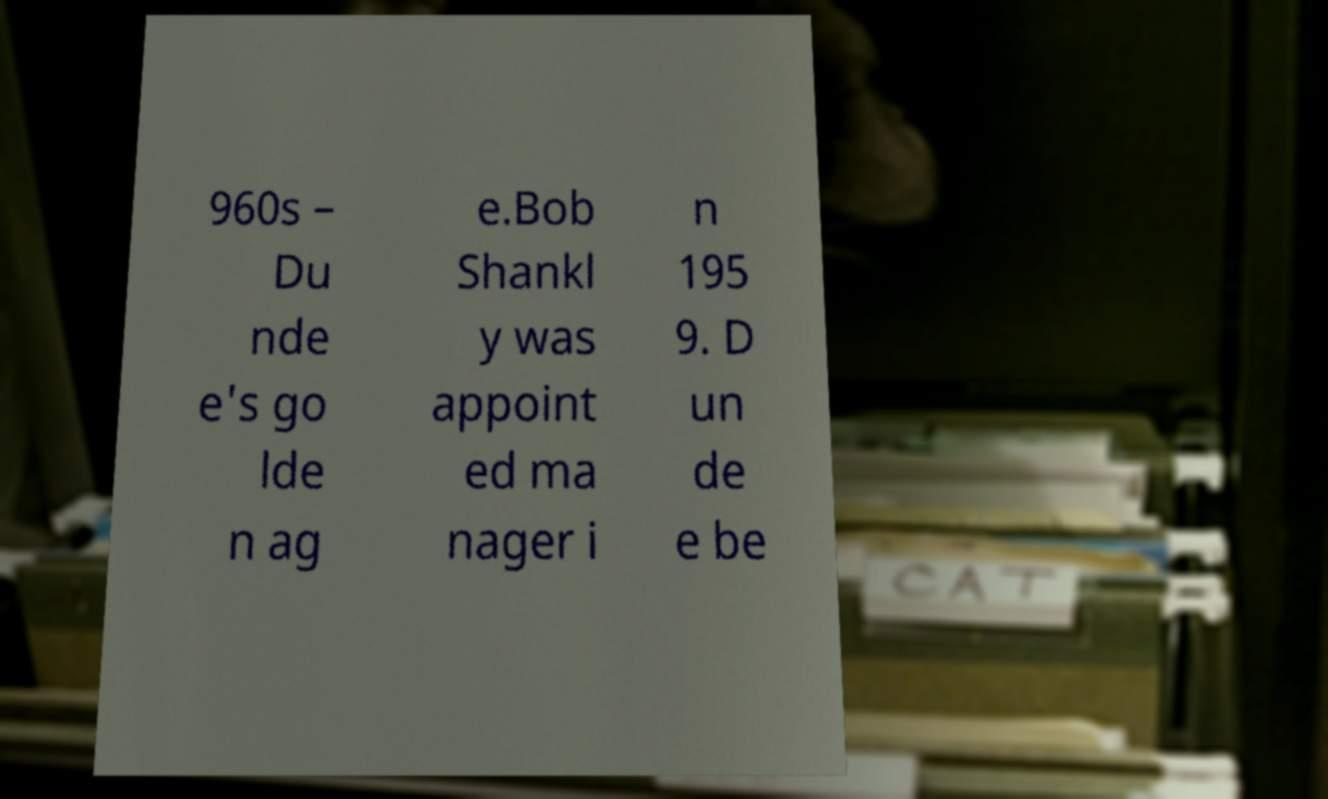Can you accurately transcribe the text from the provided image for me? 960s – Du nde e's go lde n ag e.Bob Shankl y was appoint ed ma nager i n 195 9. D un de e be 